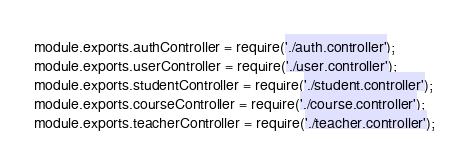<code> <loc_0><loc_0><loc_500><loc_500><_JavaScript_>module.exports.authController = require('./auth.controller');
module.exports.userController = require('./user.controller');
module.exports.studentController = require('./student.controller');
module.exports.courseController = require('./course.controller');
module.exports.teacherController = require('./teacher.controller');
</code> 